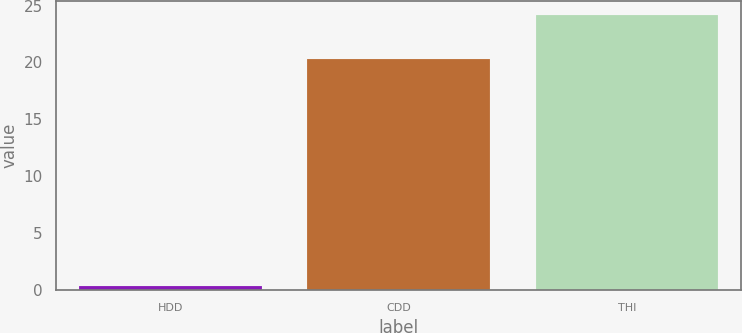Convert chart. <chart><loc_0><loc_0><loc_500><loc_500><bar_chart><fcel>HDD<fcel>CDD<fcel>THI<nl><fcel>0.4<fcel>20.3<fcel>24.2<nl></chart> 